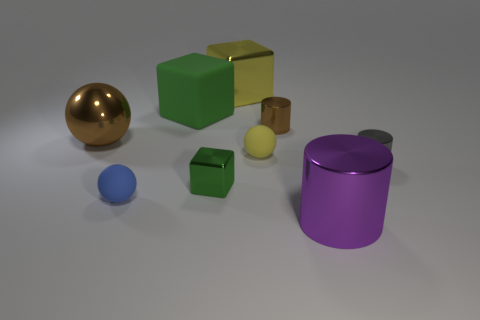Subtract all blue rubber spheres. How many spheres are left? 2 Subtract all brown cylinders. How many cylinders are left? 2 Subtract all blue cylinders. How many green blocks are left? 2 Add 1 gray cylinders. How many objects exist? 10 Subtract all cylinders. How many objects are left? 6 Subtract 2 blocks. How many blocks are left? 1 Add 1 large rubber cylinders. How many large rubber cylinders exist? 1 Subtract 0 red blocks. How many objects are left? 9 Subtract all purple spheres. Subtract all yellow blocks. How many spheres are left? 3 Subtract all blocks. Subtract all blue rubber things. How many objects are left? 5 